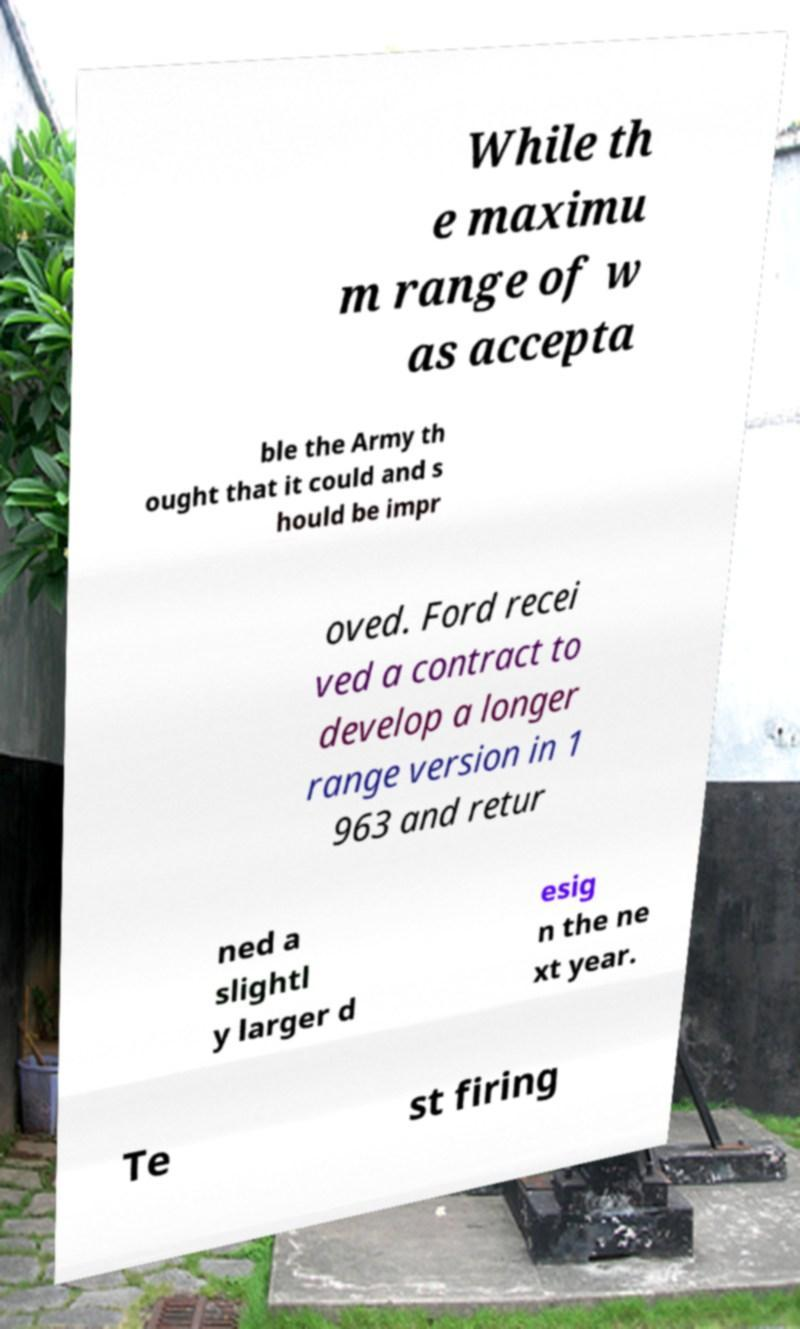I need the written content from this picture converted into text. Can you do that? While th e maximu m range of w as accepta ble the Army th ought that it could and s hould be impr oved. Ford recei ved a contract to develop a longer range version in 1 963 and retur ned a slightl y larger d esig n the ne xt year. Te st firing 